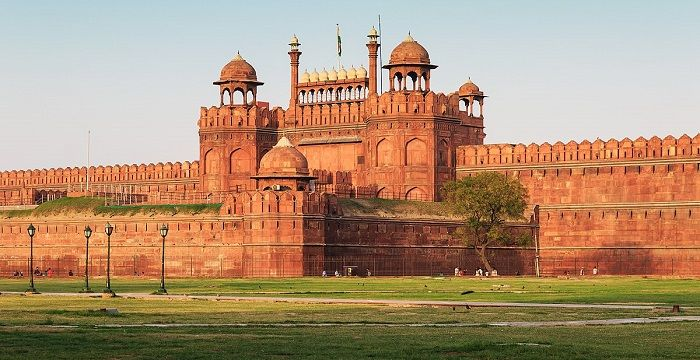Describe the following image. The image beautifully captures the Red Fort in New Delhi, India, a splendid example of Mughal architecture and a prominent UNESCO World Heritage Site. Constructed in the mid-17th century by Emperor Shah Jahan, the same ruler who commissioned the Taj Mahal, the fort's robust red sandstone walls encapsulate a rich history of India, from royal ceremonies to pivotal independence movements. The fort's Lahori Gate, visible in the image, is particularly renowned for the Independence Day speech delivered from its ramparts by the Prime Minister of India each year. The vast lawn in the foreground and the clear blue sky accentuate the imposing structure, inviting countless visitors and historians to delve into India's profound past. 